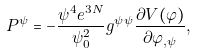Convert formula to latex. <formula><loc_0><loc_0><loc_500><loc_500>P ^ { \psi } = - \frac { \psi ^ { 4 } e ^ { 3 N } } { \psi ^ { 2 } _ { 0 } } g ^ { \psi \psi } \frac { \partial V ( \varphi ) } { \partial \varphi _ { , \psi } } ,</formula> 